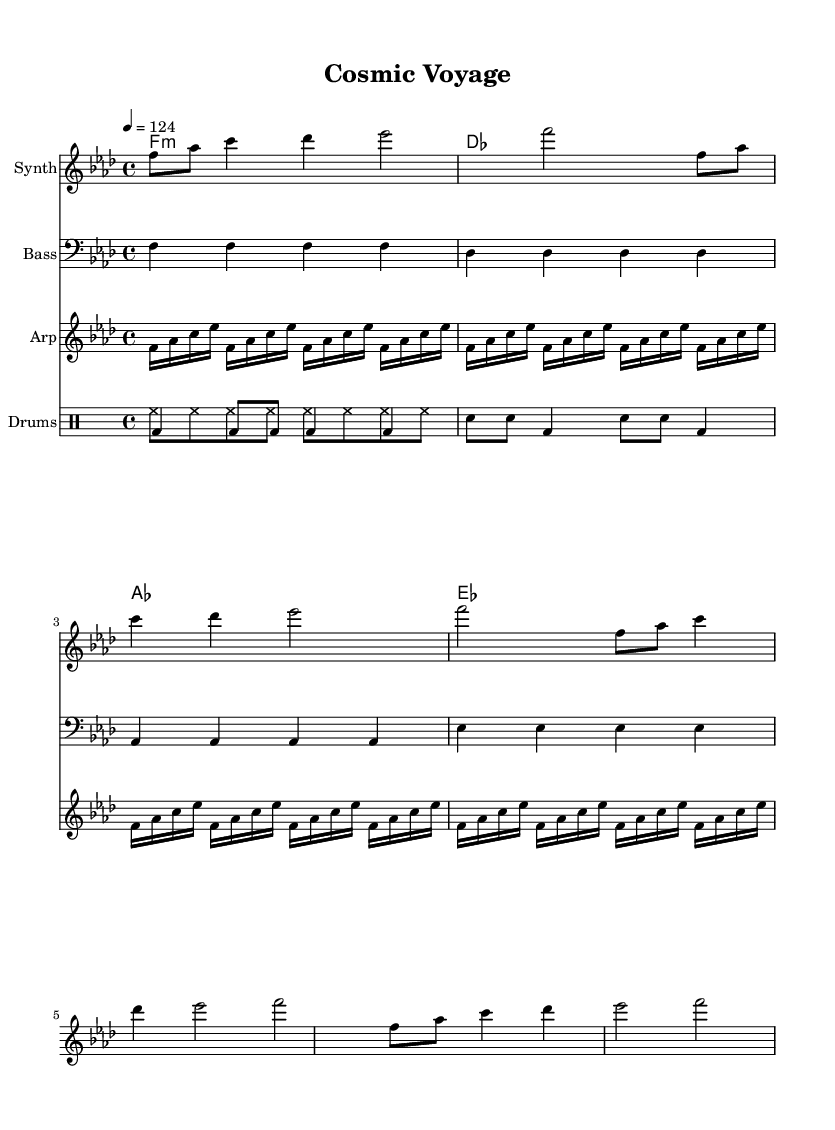What is the key signature of this music? The key signature is F minor, indicated by four flats on the staff. You can identify this by looking at the beginning of the music sheet where the key signature is placed.
Answer: F minor What is the time signature of this music? The time signature is 4/4, which is indicated at the beginning of the sheet music. The "4" on the top represents four beats in a measure, and the "4" on the bottom indicates that a quarter note receives one beat.
Answer: 4/4 What is the tempo marking for this piece? The tempo marking is 124, shown at the beginning of the score as "4 = 124". This means that there are 124 beats per minute.
Answer: 124 How many measures are in the melody section? There are 8 measures in the melody section, as indicated by the grouping of notes divided by vertical lines (bar lines) in the staff. Counting the divisions gives a total of 8 measures.
Answer: 8 What instruments are used in this score? The instruments listed in the score are Synth, Bass, Arp, and Drums, each corresponding to different staffs in the score. This can be seen from the labels in the score that identify each instrument.
Answer: Synth, Bass, Arp, Drums What type of drums are used in the drum pattern? The drum pattern consists of hi-hat, bass drum, and snare drum, which are typical elements of house music. You can identify these from the symbols used in the drummode section of the score.
Answer: Hi-hat, bass drum, snare drum How does the arpeggiator section contribute to the ambiance? The arpeggiator creates a flowing and ethereal effect with rapid sequences of notes, enhancing the cosmic feel of the music. This is recognizable as the notes are played in quick succession, adding texture to the overall sound.
Answer: Ethereal effect 